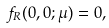Convert formula to latex. <formula><loc_0><loc_0><loc_500><loc_500>f _ { R } ( 0 , 0 ; \mu ) = 0 ,</formula> 